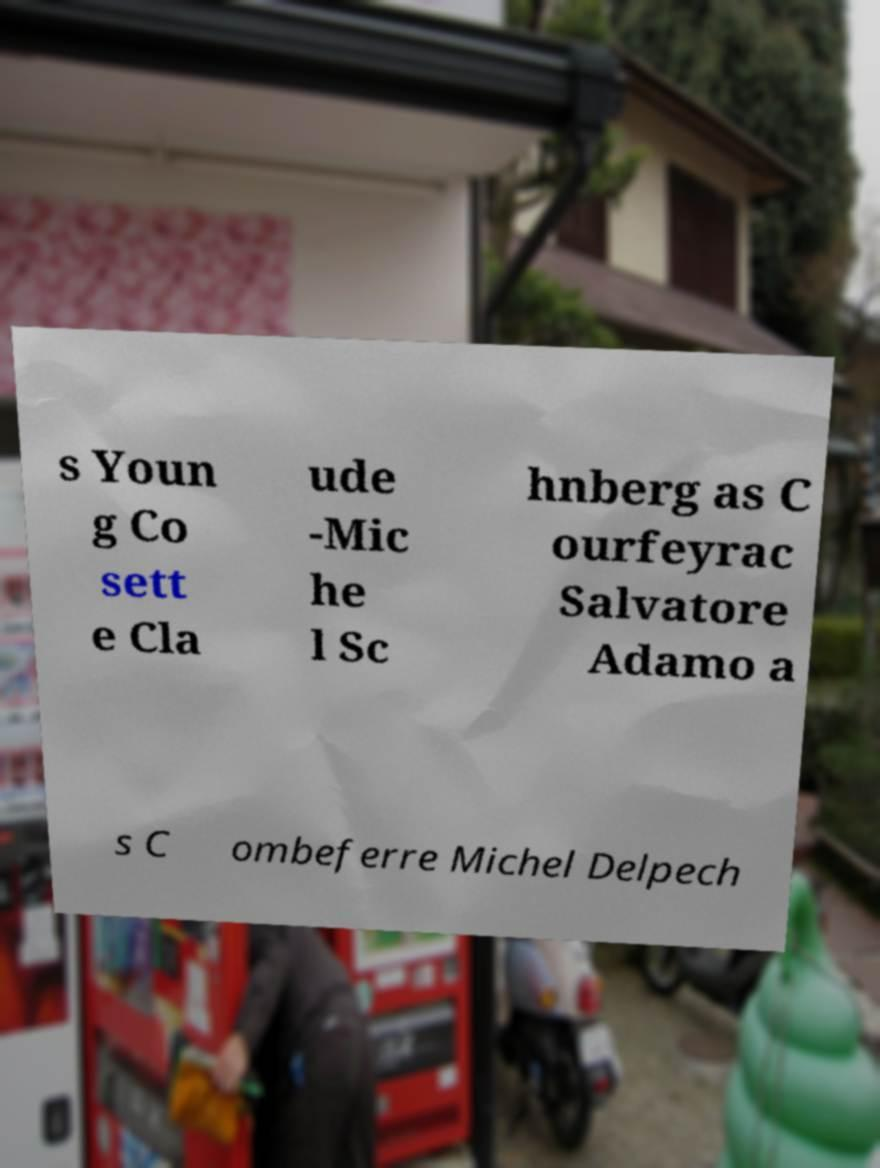There's text embedded in this image that I need extracted. Can you transcribe it verbatim? s Youn g Co sett e Cla ude -Mic he l Sc hnberg as C ourfeyrac Salvatore Adamo a s C ombeferre Michel Delpech 